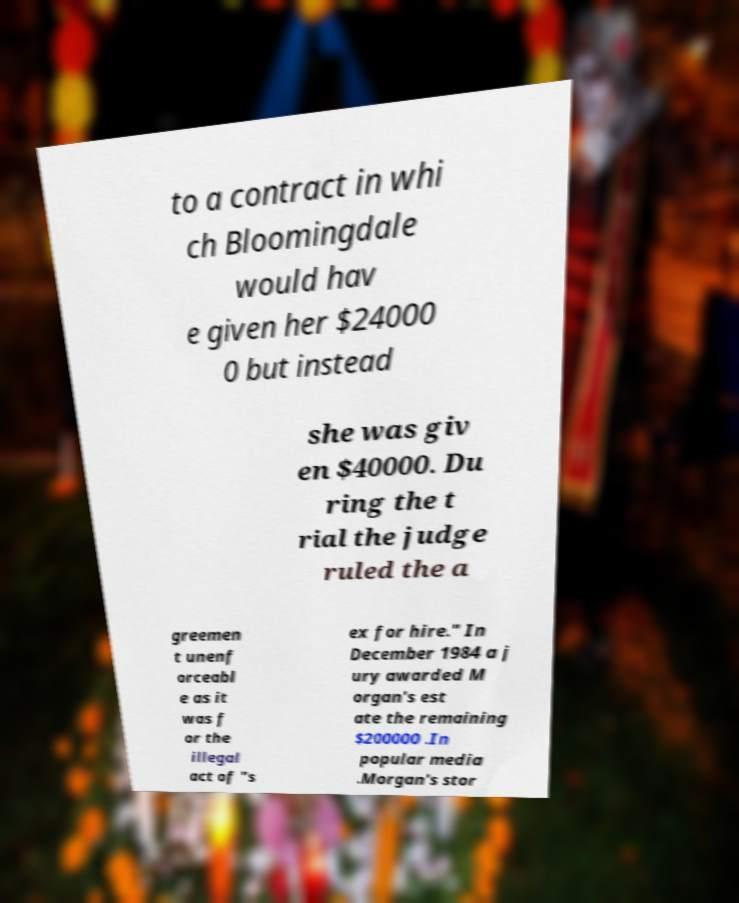Could you assist in decoding the text presented in this image and type it out clearly? to a contract in whi ch Bloomingdale would hav e given her $24000 0 but instead she was giv en $40000. Du ring the t rial the judge ruled the a greemen t unenf orceabl e as it was f or the illegal act of "s ex for hire." In December 1984 a j ury awarded M organ's est ate the remaining $200000 .In popular media .Morgan's stor 